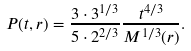<formula> <loc_0><loc_0><loc_500><loc_500>P ( t , r ) = \frac { 3 \cdot 3 ^ { 1 / 3 } } { 5 \cdot 2 ^ { 2 / 3 } } \frac { t ^ { 4 / 3 } } { M ^ { 1 / 3 } ( r ) } .</formula> 